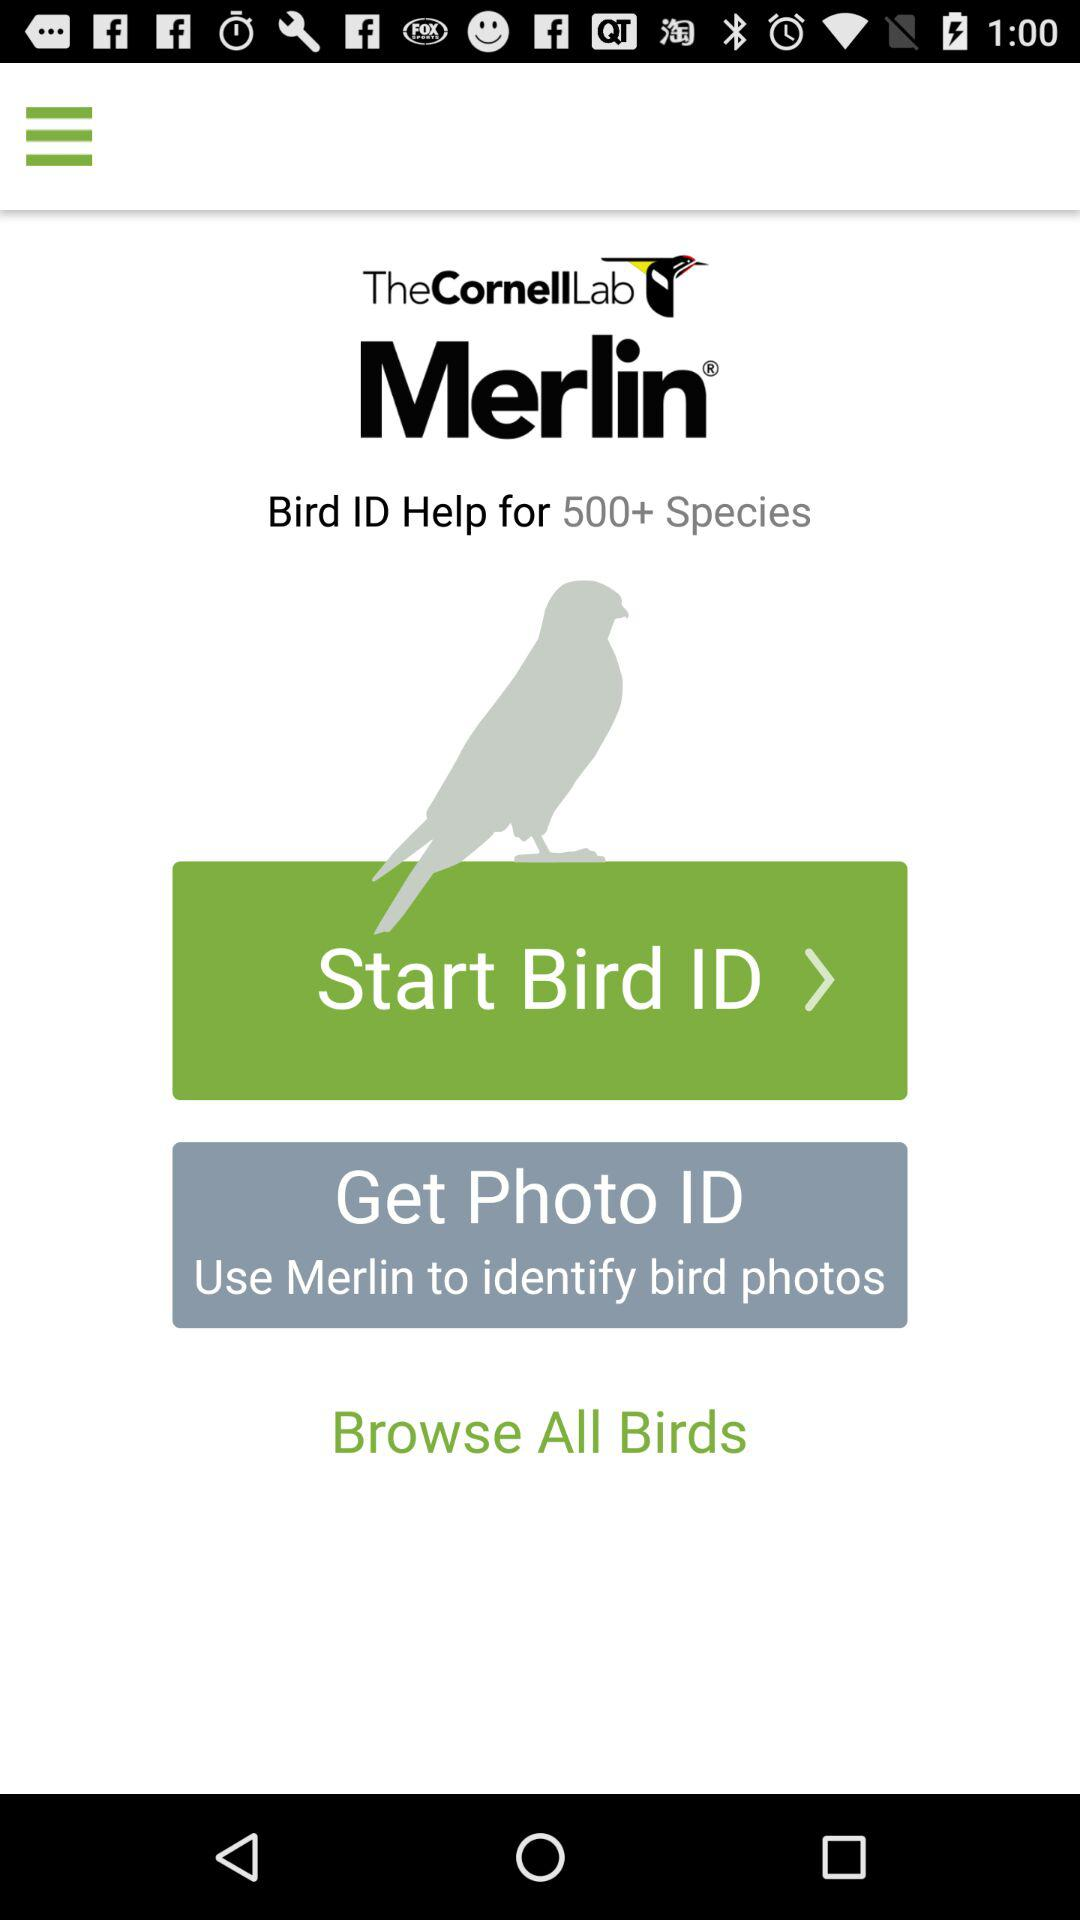What's the number of bird species the aid is for? The aid is for more than 500 bird species. 